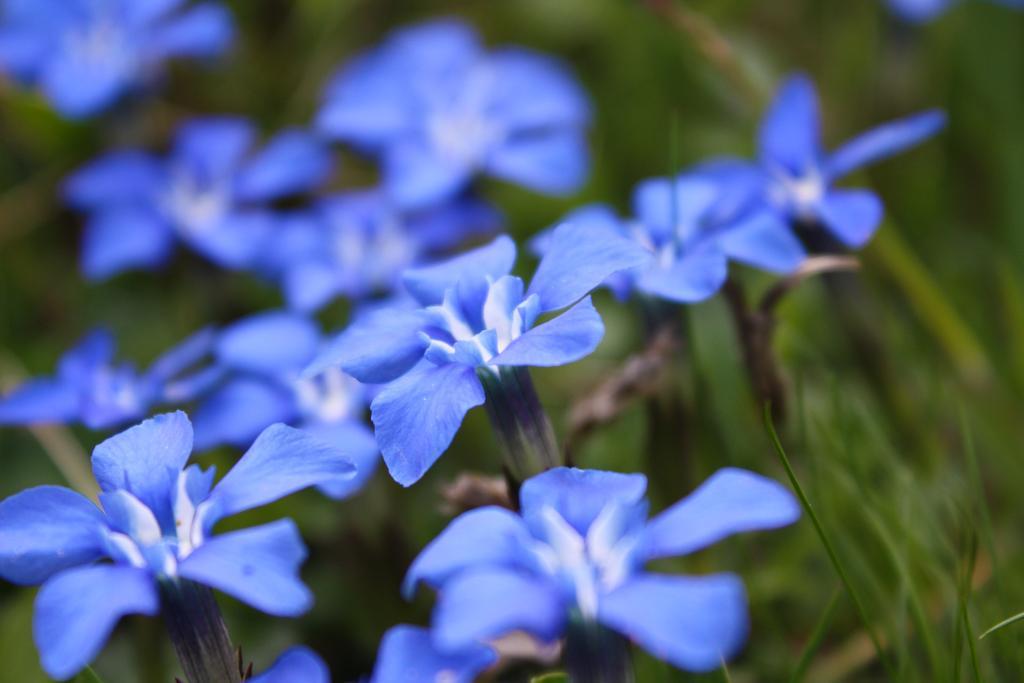Please provide a concise description of this image. In this image we can see some flowers which are in purple color, also we can see planets, and the background is blurred. 